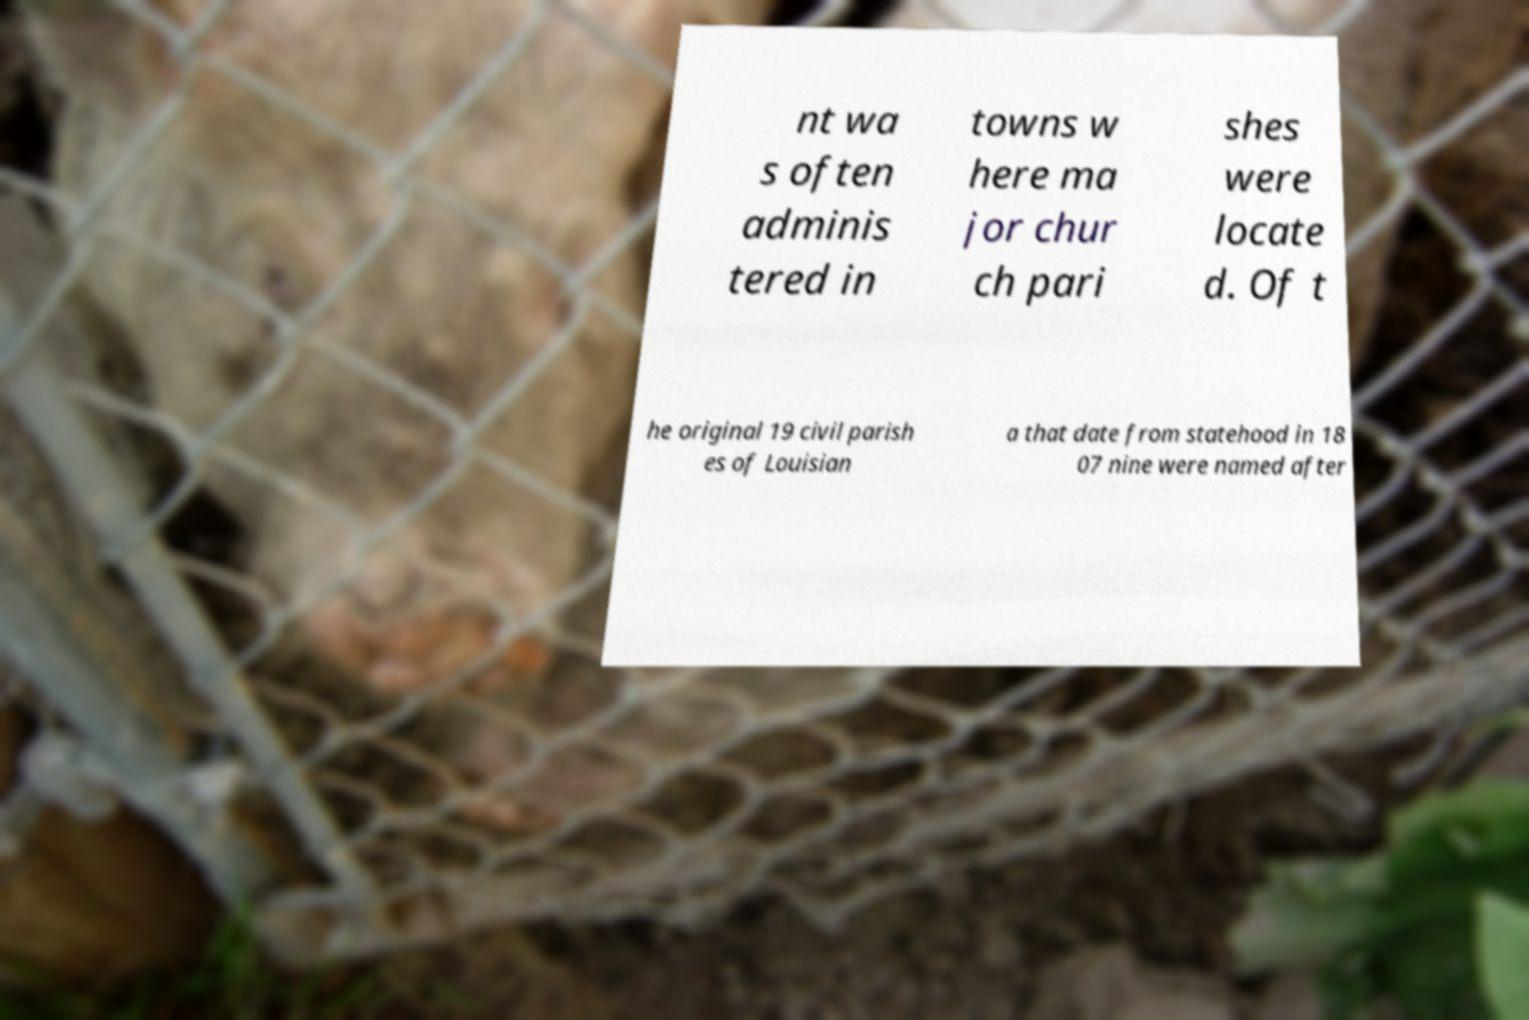Can you accurately transcribe the text from the provided image for me? nt wa s often adminis tered in towns w here ma jor chur ch pari shes were locate d. Of t he original 19 civil parish es of Louisian a that date from statehood in 18 07 nine were named after 